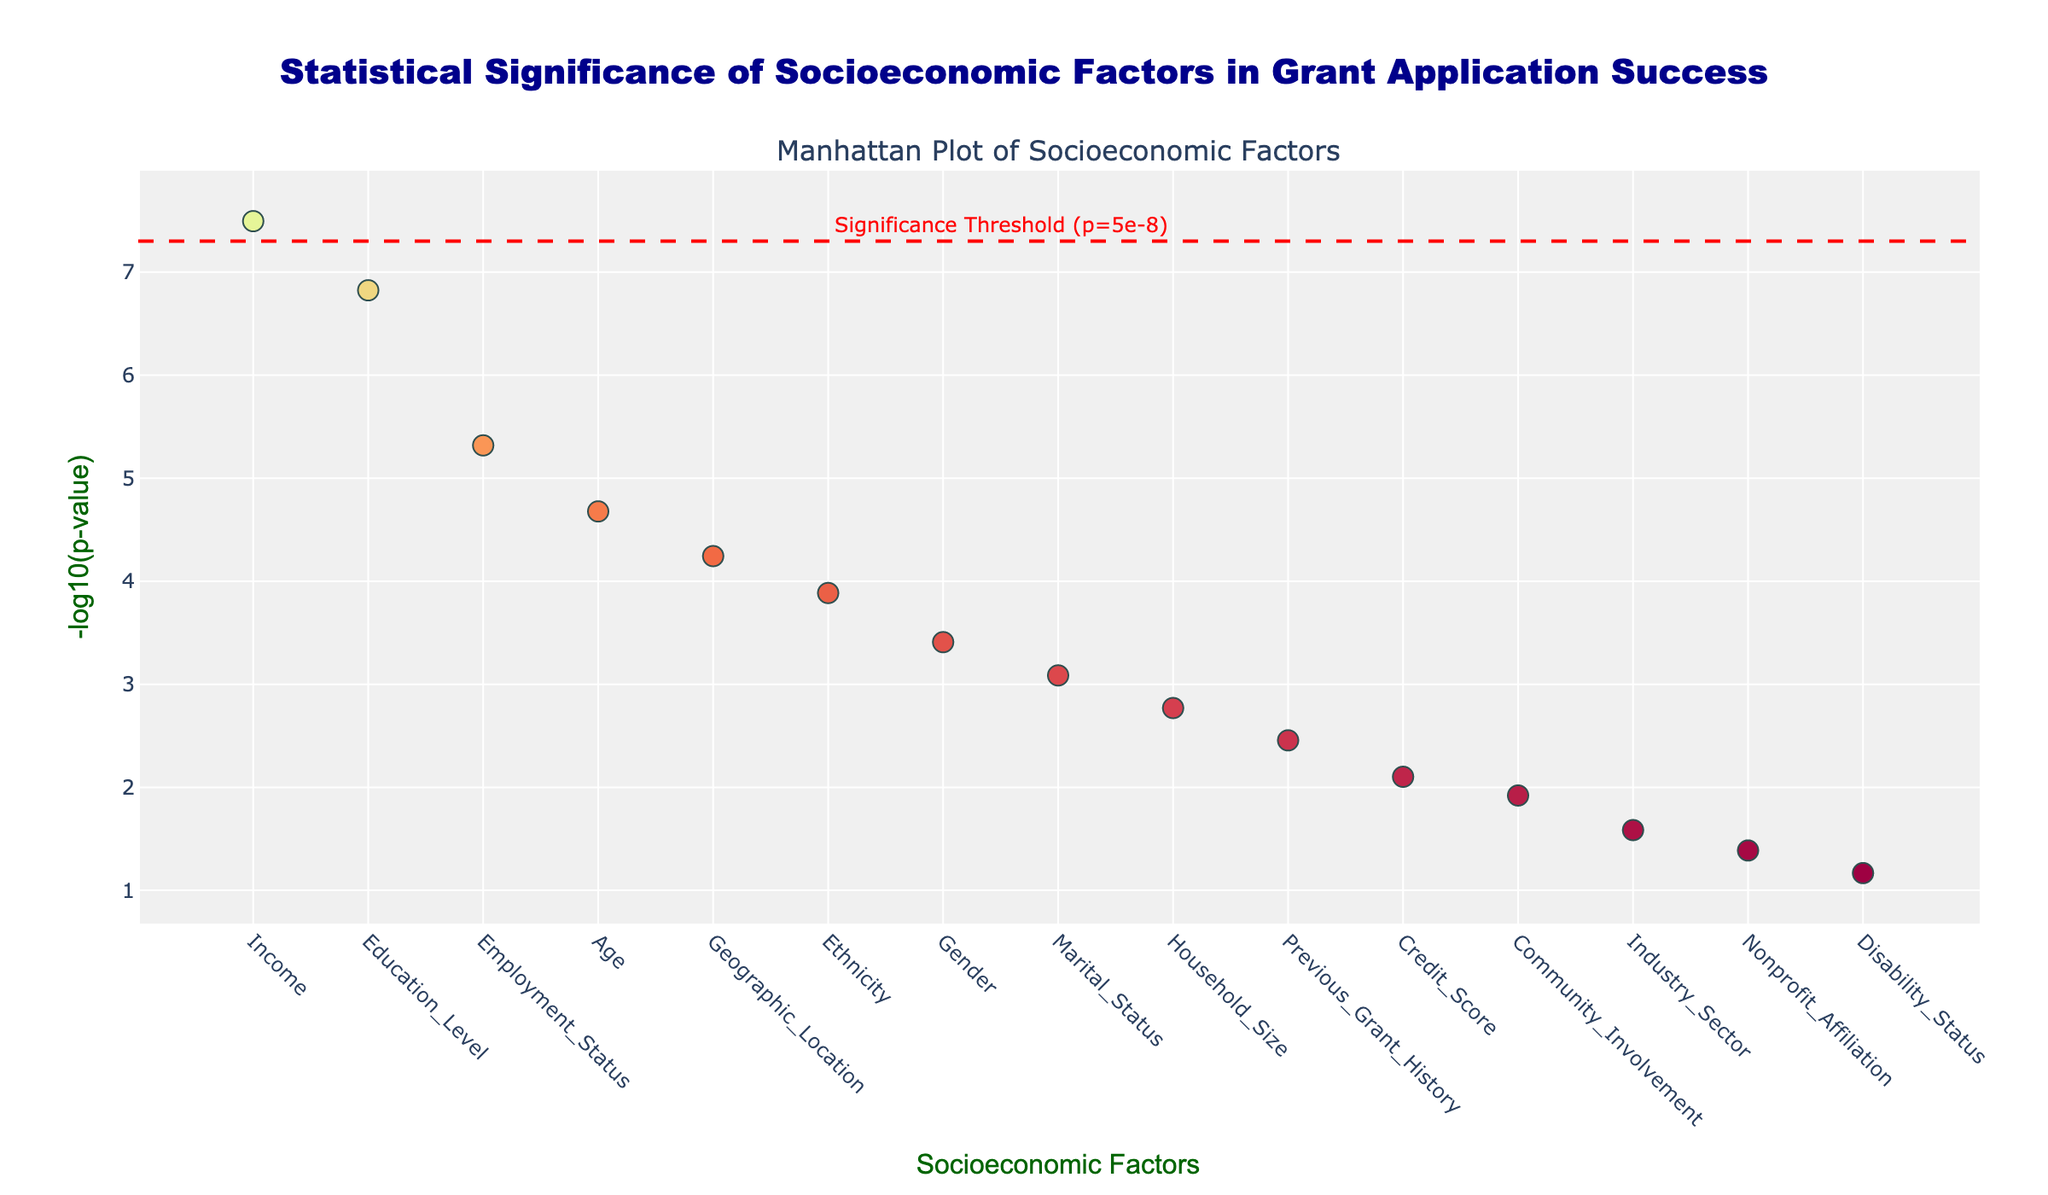What is the title of the figure? The title is usually located at the top of the figure and is prominently displayed in a larger font. In this case, the figure's title reads as "Statistical Significance of Socioeconomic Factors in Grant Application Success."
Answer: Statistical Significance of Socioeconomic Factors in Grant Application Success Which factor shows the most statistically significant influence on grant application success rates? The color scale and the y-axis of the figure indicate the level of significance. The marker with the highest value on the y-axis represents the factor with the most statistically significant influence. In this case, "Income" has the highest -log10(p-value).
Answer: Income How many socioeconomic factors are presented in the figure? Each factor is represented as a marker along the x-axis, corresponding to the tick positions. You can count these markers to determine the number of factors. There are 15 tick positions, which means there are 15 socioeconomic factors.
Answer: 15 What is the -log10(p-value) threshold indicated by the red dashed line? The threshold line is accompanied by an annotation explaining its value. According to the figure, the red dashed line represents a significance threshold at -log10(p-value) corresponding to p = 5e-8. So, we take the negative log base 10 of 5e-8, which is around 7.3.
Answer: Approximately 7.3 Which two factors have the closest -log10(p-value) values, and what are those values? By visually inspecting the height of the markers, "Credit_Score" and "Community_Involvement" have -log10(p-value) values close to each other. The -log10(p-value) for "Credit_Score" is approximately 2.1, and for "Community_Involvement," it is about 1.92.
Answer: Credit_Score: 2.1, Community_Involvement: 1.92 How many factors have -log10(p-value) values above 3? To answer this, identify the markers that are above the y-axis value of 3. "Income," "Education_Level," "Employment_Status," and "Age" have -log10(p-value) above 3. This gives us four factors.
Answer: 4 Which factor is the least statistically significant, and what is its -log10(p-value)? The factor with the lowest marker on the y-axis has the least statistical significance. "Disability_Status" appears to have the lowest -log10(p-value), approximated at around 1.16.
Answer: Disability_Status, 1.16 Is there any factor whose -log10(p-value) is below 2? If so, identify it or them. To find this, look for markers below the y-axis value of 2. "Nonprofit_Affiliation" and "Disability_Status" fall below this threshold.
Answer: Nonprofit_Affiliation, Disability_Status What is the range of -log10(p-value) values for the factors shown in the figure? The range is calculated by finding the difference between the maximum and minimum -log10(p-value) values. The maximum is around 7.5 (Income), and the minimum is around 1.16 (Disability_Status), so the range is 7.5 - 1.16 = 6.34.
Answer: 6.34 